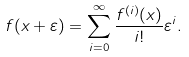Convert formula to latex. <formula><loc_0><loc_0><loc_500><loc_500>f ( x + \varepsilon ) = \sum _ { i = 0 } ^ { \infty } \frac { f ^ { ( i ) } ( x ) } { i ! } \varepsilon ^ { i } .</formula> 